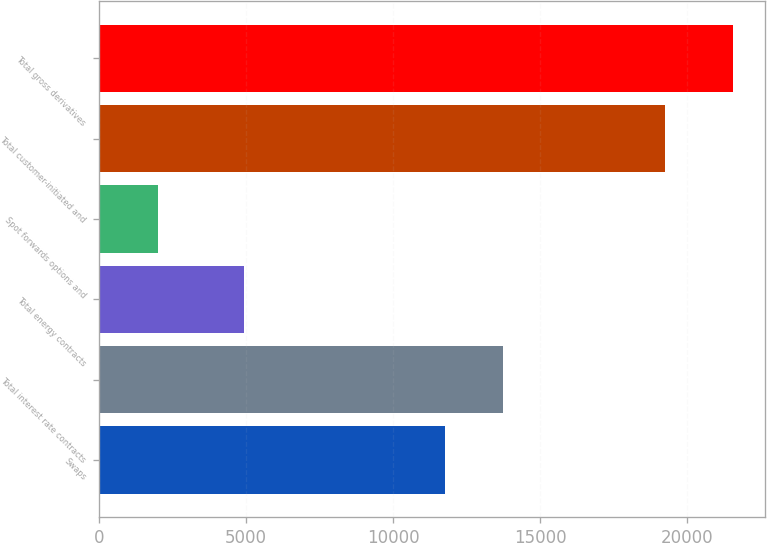Convert chart. <chart><loc_0><loc_0><loc_500><loc_500><bar_chart><fcel>Swaps<fcel>Total interest rate contracts<fcel>Total energy contracts<fcel>Spot forwards options and<fcel>Total customer-initiated and<fcel>Total gross derivatives<nl><fcel>11780<fcel>13736.8<fcel>4932<fcel>1994<fcel>19254<fcel>21562<nl></chart> 